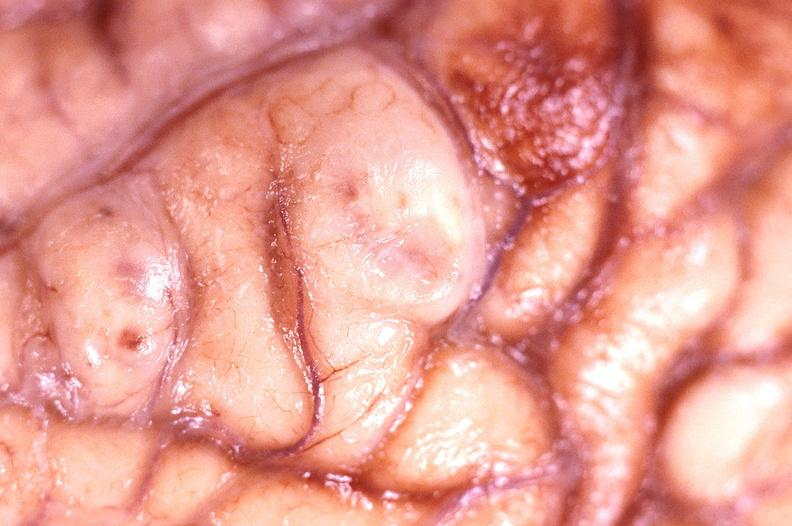what is present?
Answer the question using a single word or phrase. Nervous 